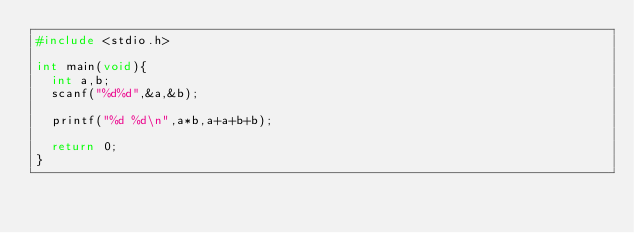<code> <loc_0><loc_0><loc_500><loc_500><_C_>#include <stdio.h>

int main(void){
  int a,b;
  scanf("%d%d",&a,&b);

  printf("%d %d\n",a*b,a+a+b+b);

  return 0;
}</code> 